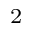Convert formula to latex. <formula><loc_0><loc_0><loc_500><loc_500>^ { 2 }</formula> 